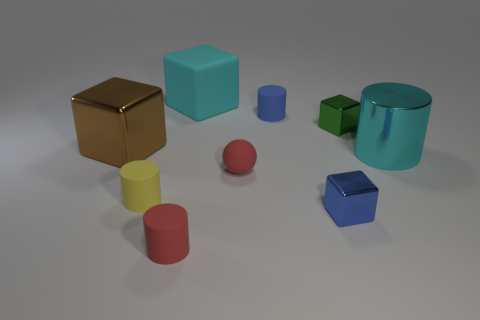Add 1 red balls. How many objects exist? 10 Subtract all blocks. How many objects are left? 5 Subtract all brown cubes. Subtract all tiny red matte balls. How many objects are left? 7 Add 6 red matte objects. How many red matte objects are left? 8 Add 8 large cyan things. How many large cyan things exist? 10 Subtract 0 purple spheres. How many objects are left? 9 